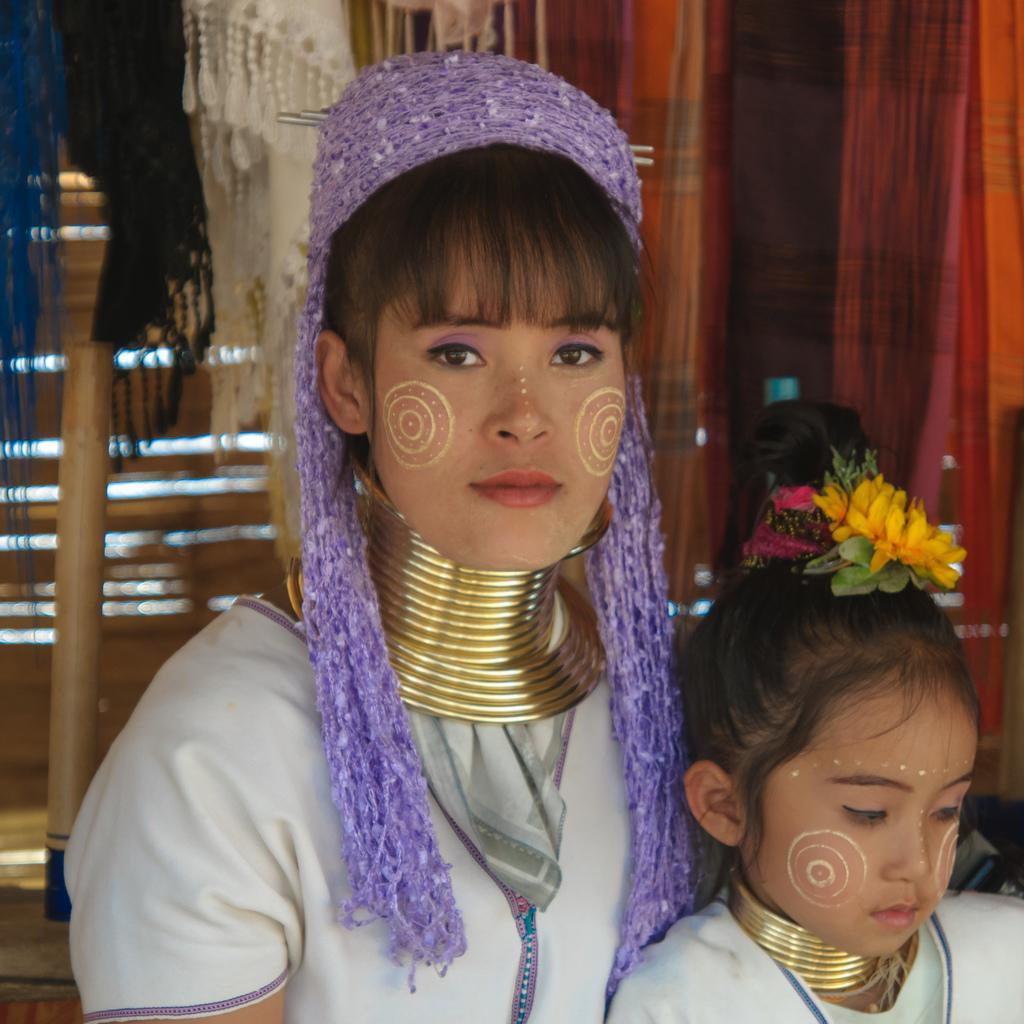Please provide a concise description of this image. In the center of the image we can see two persons are there. In the background of the image we can see some clothes, wall. At the bottom left corner there is a floor. 